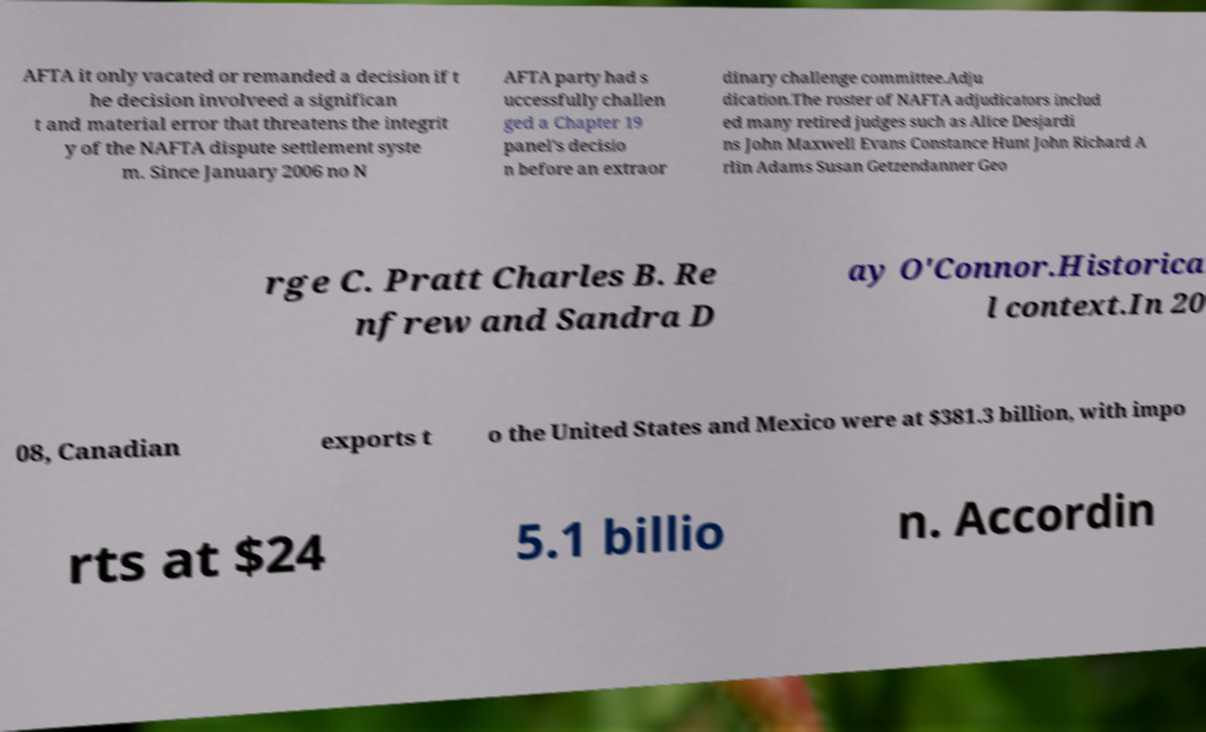Can you accurately transcribe the text from the provided image for me? AFTA it only vacated or remanded a decision if t he decision involveed a significan t and material error that threatens the integrit y of the NAFTA dispute settlement syste m. Since January 2006 no N AFTA party had s uccessfully challen ged a Chapter 19 panel's decisio n before an extraor dinary challenge committee.Adju dication.The roster of NAFTA adjudicators includ ed many retired judges such as Alice Desjardi ns John Maxwell Evans Constance Hunt John Richard A rlin Adams Susan Getzendanner Geo rge C. Pratt Charles B. Re nfrew and Sandra D ay O'Connor.Historica l context.In 20 08, Canadian exports t o the United States and Mexico were at $381.3 billion, with impo rts at $24 5.1 billio n. Accordin 